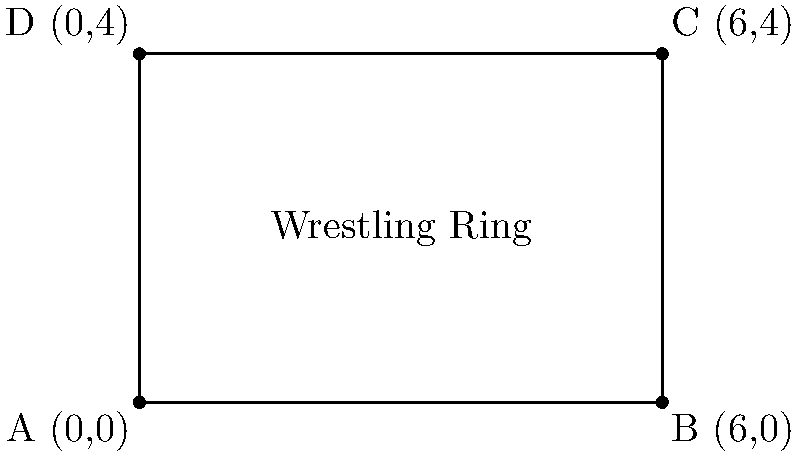In a Japanese women's professional wrestling match, the ring is represented on a coordinate plane as shown in the diagram. If each unit on the graph represents 1 meter, what is the area of the wrestling ring in square meters? To find the area of the wrestling ring, we need to follow these steps:

1. Identify the shape: The wrestling ring is represented as a rectangle on the coordinate plane.

2. Find the length: 
   The length is the distance between points A and B.
   Length = $x_B - x_A = 6 - 0 = 6$ meters

3. Find the width:
   The width is the distance between points A and D.
   Width = $y_D - y_A = 4 - 0 = 4$ meters

4. Calculate the area:
   Area of a rectangle = length × width
   Area = $6 \times 4 = 24$ square meters

Therefore, the area of the wrestling ring is 24 square meters.
Answer: 24 m² 